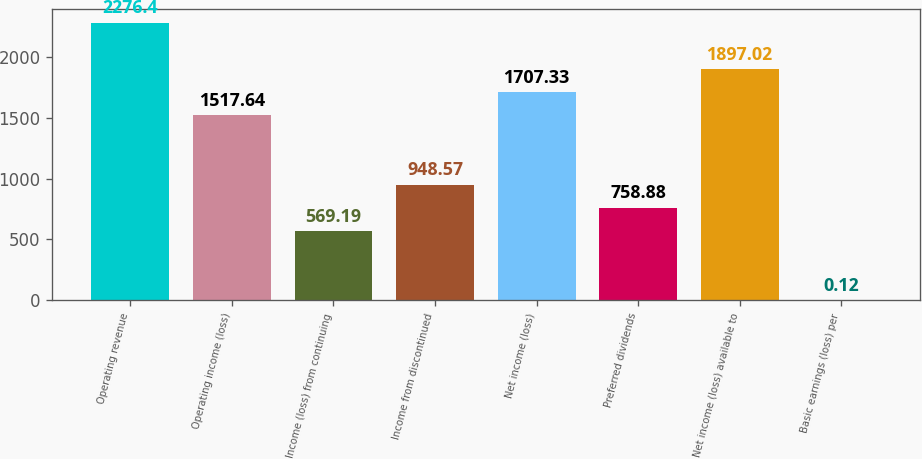Convert chart to OTSL. <chart><loc_0><loc_0><loc_500><loc_500><bar_chart><fcel>Operating revenue<fcel>Operating income (loss)<fcel>Income (loss) from continuing<fcel>Income from discontinued<fcel>Net income (loss)<fcel>Preferred dividends<fcel>Net income (loss) available to<fcel>Basic earnings (loss) per<nl><fcel>2276.4<fcel>1517.64<fcel>569.19<fcel>948.57<fcel>1707.33<fcel>758.88<fcel>1897.02<fcel>0.12<nl></chart> 